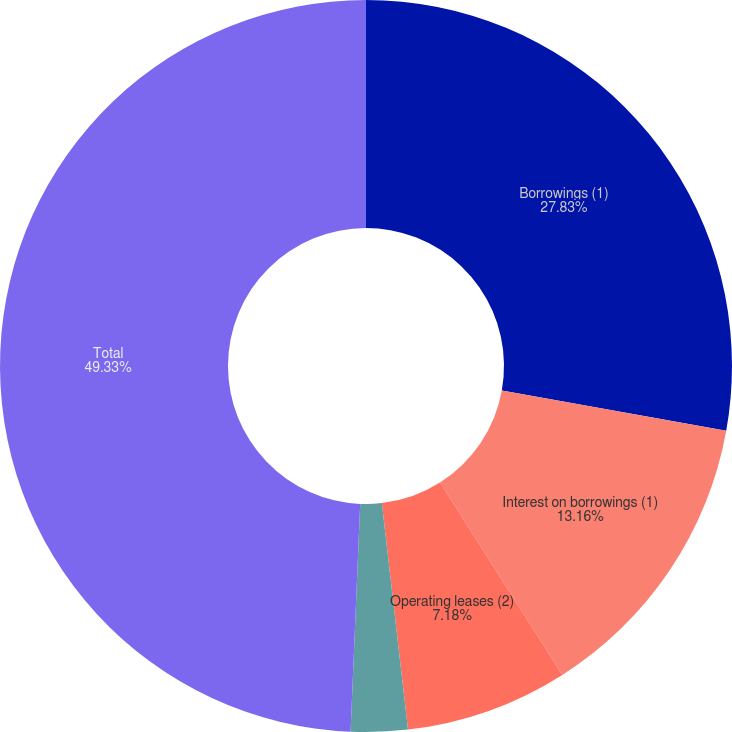Convert chart. <chart><loc_0><loc_0><loc_500><loc_500><pie_chart><fcel>Borrowings (1)<fcel>Interest on borrowings (1)<fcel>Operating leases (2)<fcel>Postretirement obligations (4)<fcel>Total<nl><fcel>27.83%<fcel>13.16%<fcel>7.18%<fcel>2.5%<fcel>49.33%<nl></chart> 